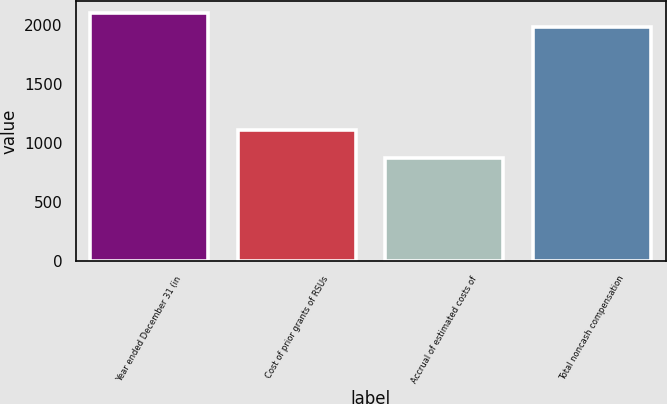Convert chart to OTSL. <chart><loc_0><loc_0><loc_500><loc_500><bar_chart><fcel>Year ended December 31 (in<fcel>Cost of prior grants of RSUs<fcel>Accrual of estimated costs of<fcel>Total noncash compensation<nl><fcel>2100.7<fcel>1109<fcel>878<fcel>1987<nl></chart> 